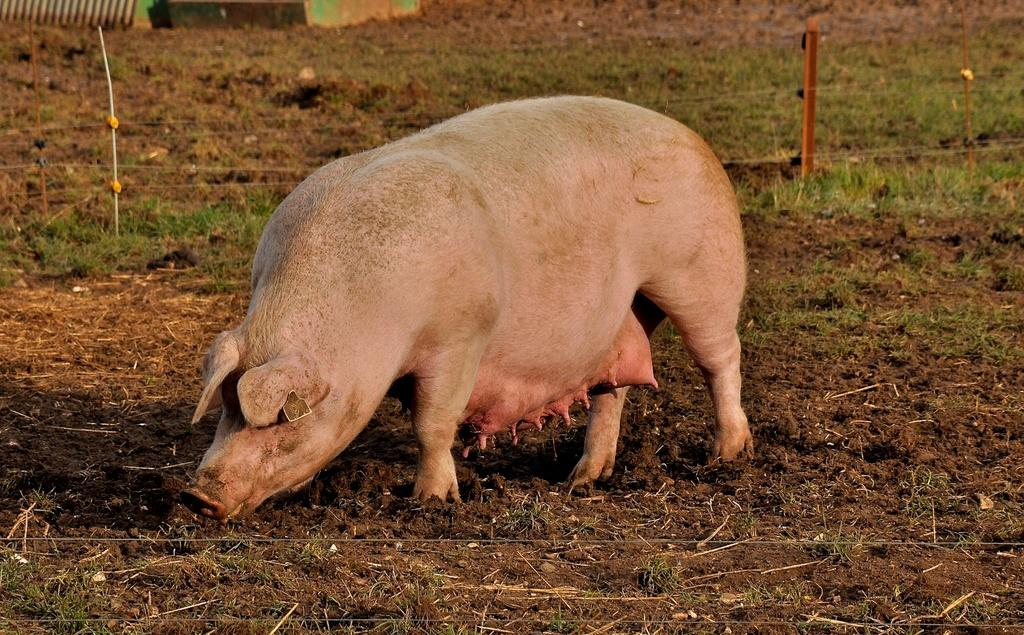What animal is present in the image? There is a pig in the image. What color is the pig? The pig is pink in color. What is the pig's position in the image? The pig is standing on the ground. What type of barrier can be seen in the image? There is fencing visible in the image. What type of vegetation is present on the ground in the image? There is grass on the ground in the image. Can you hear the hen laughing in the image? There is no hen present in the image, and therefore no laughter can be heard. 